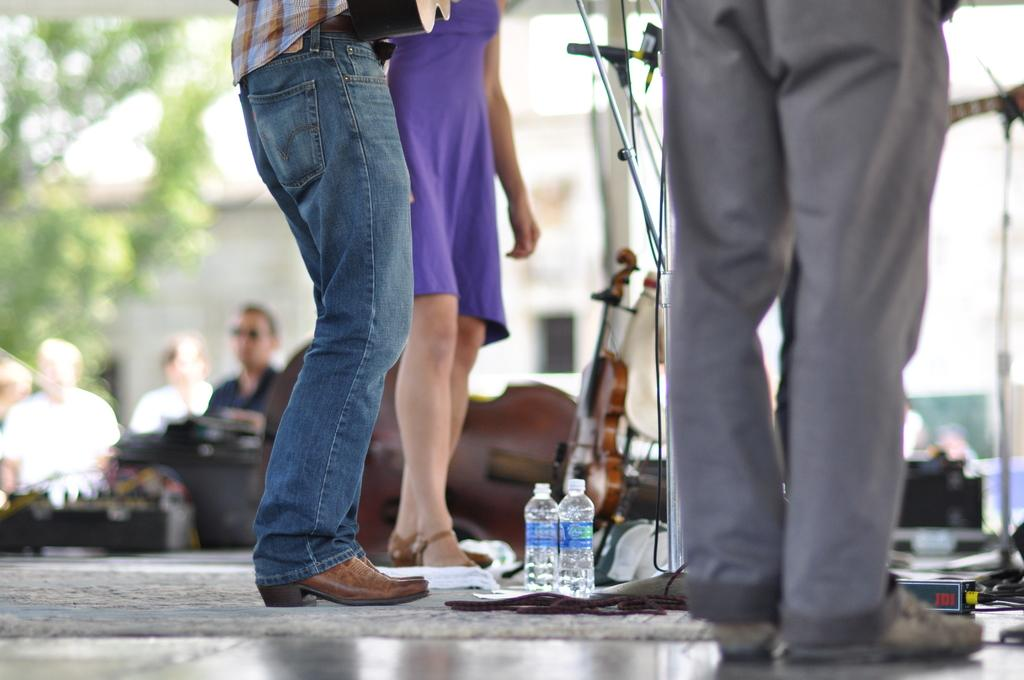Who or what can be seen in the image? There are people in the image. Where are the people located in relation to the image? The people are standing on the floor in the middle of the image. What type of root can be seen growing from the floor in the image? There is no root visible in the image; the people are standing on the floor. 